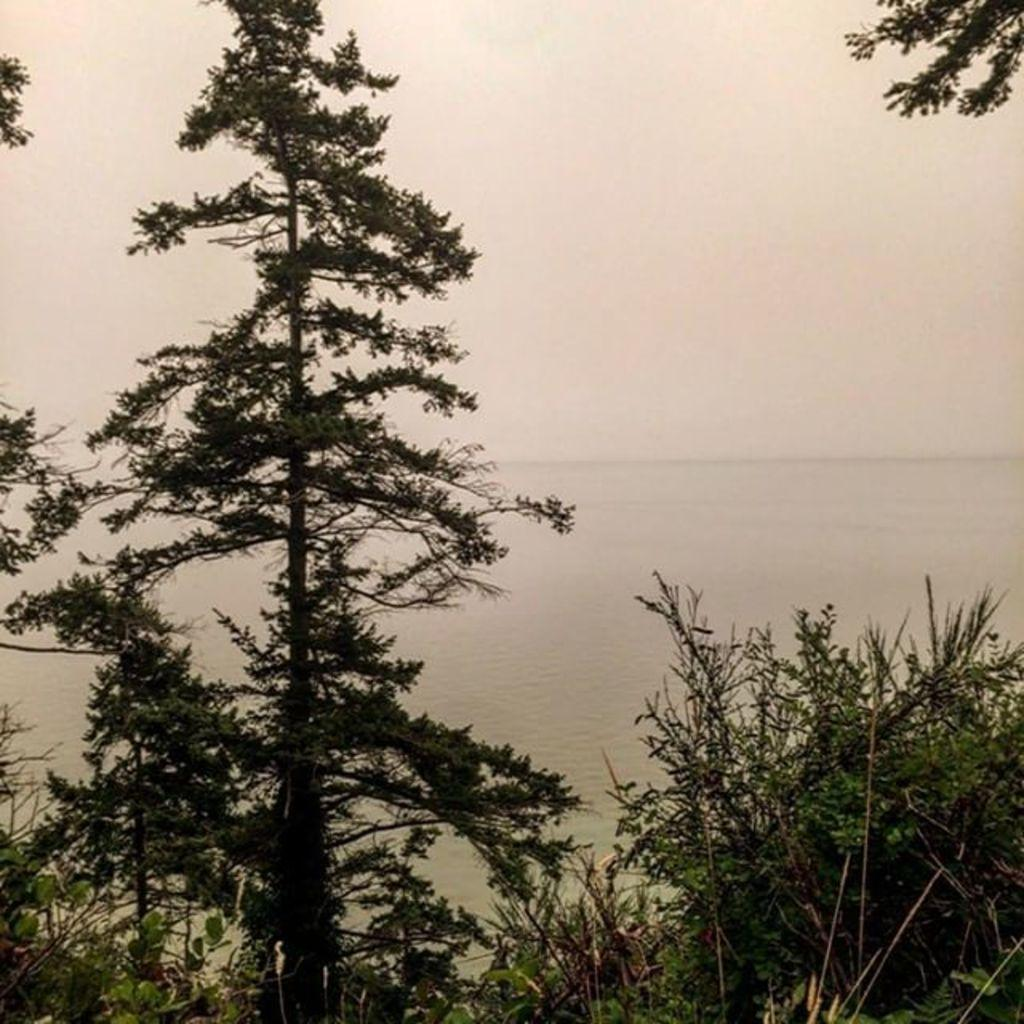What type of vegetation can be seen in the image? There are trees in the image. What can be seen in the background of the image? There is water and the sky visible in the background of the image. Where is the grandmother sitting with her feathered hat in the image? There is no grandmother or feathered hat present in the image. 